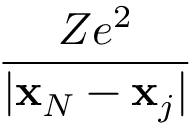<formula> <loc_0><loc_0><loc_500><loc_500>\frac { Z e ^ { 2 } } { | x _ { N } - x _ { j } | }</formula> 